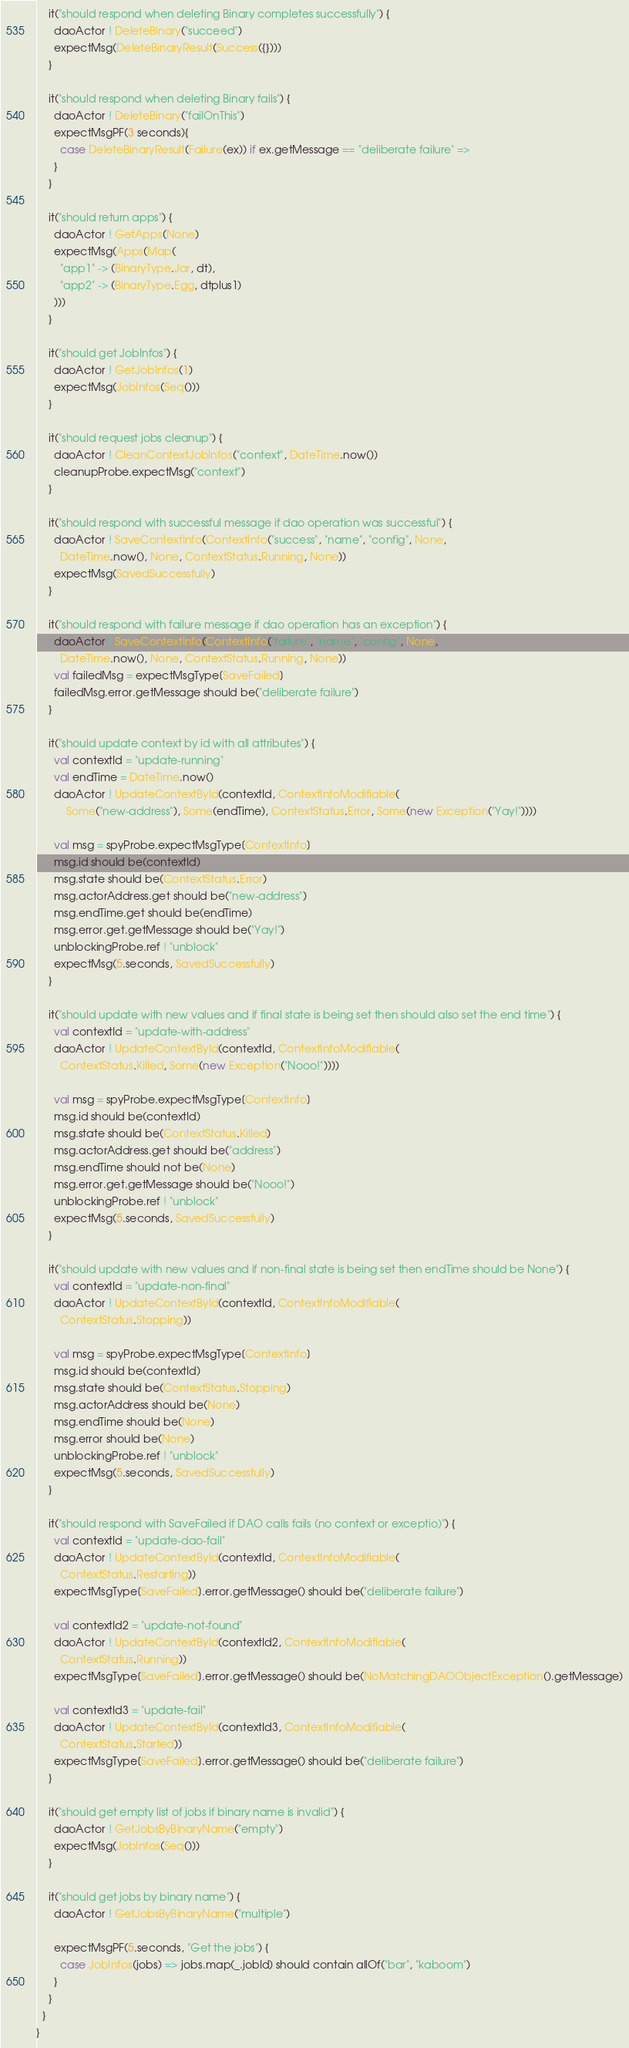<code> <loc_0><loc_0><loc_500><loc_500><_Scala_>    it("should respond when deleting Binary completes successfully") {
      daoActor ! DeleteBinary("succeed")
      expectMsg(DeleteBinaryResult(Success({})))
    }

    it("should respond when deleting Binary fails") {
      daoActor ! DeleteBinary("failOnThis")
      expectMsgPF(3 seconds){
        case DeleteBinaryResult(Failure(ex)) if ex.getMessage == "deliberate failure" =>
      }
    }

    it("should return apps") {
      daoActor ! GetApps(None)
      expectMsg(Apps(Map(
        "app1" -> (BinaryType.Jar, dt),
        "app2" -> (BinaryType.Egg, dtplus1)
      )))
    }

    it("should get JobInfos") {
      daoActor ! GetJobInfos(1)
      expectMsg(JobInfos(Seq()))
    }

    it("should request jobs cleanup") {
      daoActor ! CleanContextJobInfos("context", DateTime.now())
      cleanupProbe.expectMsg("context")
    }

    it("should respond with successful message if dao operation was successful") {
      daoActor ! SaveContextInfo(ContextInfo("success", "name", "config", None,
        DateTime.now(), None, ContextStatus.Running, None))
      expectMsg(SavedSuccessfully)
    }

    it("should respond with failure message if dao operation has an exception") {
      daoActor ! SaveContextInfo(ContextInfo("failure", "name", "config", None,
        DateTime.now(), None, ContextStatus.Running, None))
      val failedMsg = expectMsgType[SaveFailed]
      failedMsg.error.getMessage should be("deliberate failure")
    }

    it("should update context by id with all attributes") {
      val contextId = "update-running"
      val endTime = DateTime.now()
      daoActor ! UpdateContextById(contextId, ContextInfoModifiable(
          Some("new-address"), Some(endTime), ContextStatus.Error, Some(new Exception("Yay!"))))

      val msg = spyProbe.expectMsgType[ContextInfo]
      msg.id should be(contextId)
      msg.state should be(ContextStatus.Error)
      msg.actorAddress.get should be("new-address")
      msg.endTime.get should be(endTime)
      msg.error.get.getMessage should be("Yay!")
      unblockingProbe.ref ! "unblock"
      expectMsg(5.seconds, SavedSuccessfully)
    }

    it("should update with new values and if final state is being set then should also set the end time") {
      val contextId = "update-with-address"
      daoActor ! UpdateContextById(contextId, ContextInfoModifiable(
        ContextStatus.Killed, Some(new Exception("Nooo!"))))

      val msg = spyProbe.expectMsgType[ContextInfo]
      msg.id should be(contextId)
      msg.state should be(ContextStatus.Killed)
      msg.actorAddress.get should be("address")
      msg.endTime should not be(None)
      msg.error.get.getMessage should be("Nooo!")
      unblockingProbe.ref ! "unblock"
      expectMsg(5.seconds, SavedSuccessfully)
    }

    it("should update with new values and if non-final state is being set then endTime should be None") {
      val contextId = "update-non-final"
      daoActor ! UpdateContextById(contextId, ContextInfoModifiable(
        ContextStatus.Stopping))

      val msg = spyProbe.expectMsgType[ContextInfo]
      msg.id should be(contextId)
      msg.state should be(ContextStatus.Stopping)
      msg.actorAddress should be(None)
      msg.endTime should be(None)
      msg.error should be(None)
      unblockingProbe.ref ! "unblock"
      expectMsg(5.seconds, SavedSuccessfully)
    }

    it("should respond with SaveFailed if DAO calls fails (no context or exceptio)") {
      val contextId = "update-dao-fail"
      daoActor ! UpdateContextById(contextId, ContextInfoModifiable(
        ContextStatus.Restarting))
      expectMsgType[SaveFailed].error.getMessage() should be("deliberate failure")

      val contextId2 = "update-not-found"
      daoActor ! UpdateContextById(contextId2, ContextInfoModifiable(
        ContextStatus.Running))
      expectMsgType[SaveFailed].error.getMessage() should be(NoMatchingDAOObjectException().getMessage)

      val contextId3 = "update-fail"
      daoActor ! UpdateContextById(contextId3, ContextInfoModifiable(
        ContextStatus.Started))
      expectMsgType[SaveFailed].error.getMessage() should be("deliberate failure")
    }

    it("should get empty list of jobs if binary name is invalid") {
      daoActor ! GetJobsByBinaryName("empty")
      expectMsg(JobInfos(Seq()))
    }

    it("should get jobs by binary name") {
      daoActor ! GetJobsByBinaryName("multiple")

      expectMsgPF(5.seconds, "Get the jobs") {
        case JobInfos(jobs) => jobs.map(_.jobId) should contain allOf("bar", "kaboom")
      }
    }
  }
}
</code> 